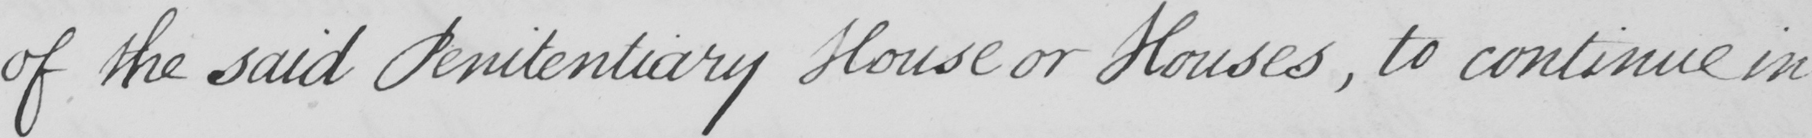What does this handwritten line say? of the said Penitentiary House or Houses  , to continue in 